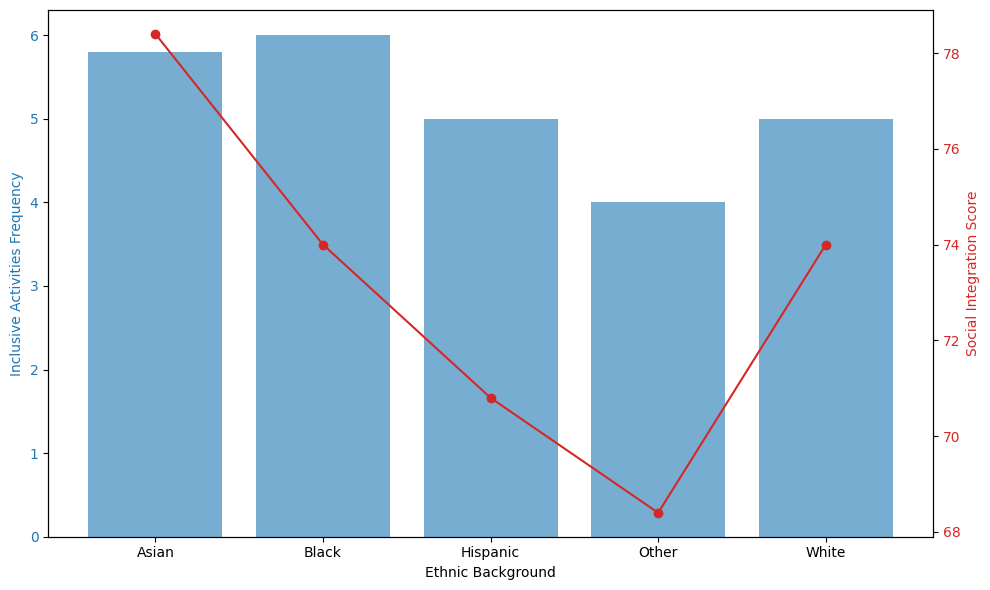Which ethnic background has the highest average frequency of inclusive activities? Observe the heights of the blue bars for each ethnic background. The "Asian" bar is the tallest, indicating that Asian students have the highest average frequency of inclusive activities.
Answer: Asian How does the Social Integration Score for White students compare with that for Black students? Look at the red line plot, specifically at the markers for White and Black students. The marker for Black students is at Social Integration Score 74, and for White students, it is at 74, indicating they are equal.
Answer: Equal Which ethnic background shows the largest difference between Inclusive Activities Frequency and Social Integration Score? Calculate the difference for each ethnic background using the bar heights and line markers. For Other: 2 to 60, White: 4 to 78, Hispanic: 3 to 73, Black: 4 to 74, Asian: 5 to 85. The maximum difference is for Other (60-2 = 58).
Answer: Other Is there a general trend in the relationship between Inclusive Activities Frequency and Social Integration Score across ethnic backgrounds? Compare the frequencies with the integration scores visually. Both metrics appear to increase together for each ethnic group, showing a positive correlation.
Answer: Yes, there is a positive correlation What is the total Inclusive Activities Frequency for all ethnic backgrounds combined? Sum up the average Inclusive Activities Frequency for Asian (5), Black (4), Hispanic (3), White (4), Other (2). The total is 18.
Answer: 18 Is there any ethnic background where the average Social Integration Score is below 70? Check the red line markers indicating Social Integration Scores. No ethnic group has a score below 70. The lowest score is 70 (White).
Answer: No Which ethnic background has the smallest range between Inclusive Activities Frequency and Social Integration Score? Calculate the absolute difference for each background. Asian: 5 to 85 (80), Black: 4 to 74 (70), Hispanic: 3 to 73 (70), White: 4 to 78 (74), Other: 2 to 60 (58). The smallest is for Other (58).
Answer: Other By how many points is the Social Integration Score for Asian students higher than for Hispanic students? Look at the red lines for Asian (85) and Hispanic (73). Subtract 73 from 85.
Answer: 12 What color represents the Social Integration Score in the figure? Visually identify the color of the line representing Social Integration Scores on the secondary y-axis. It is red.
Answer: Red 